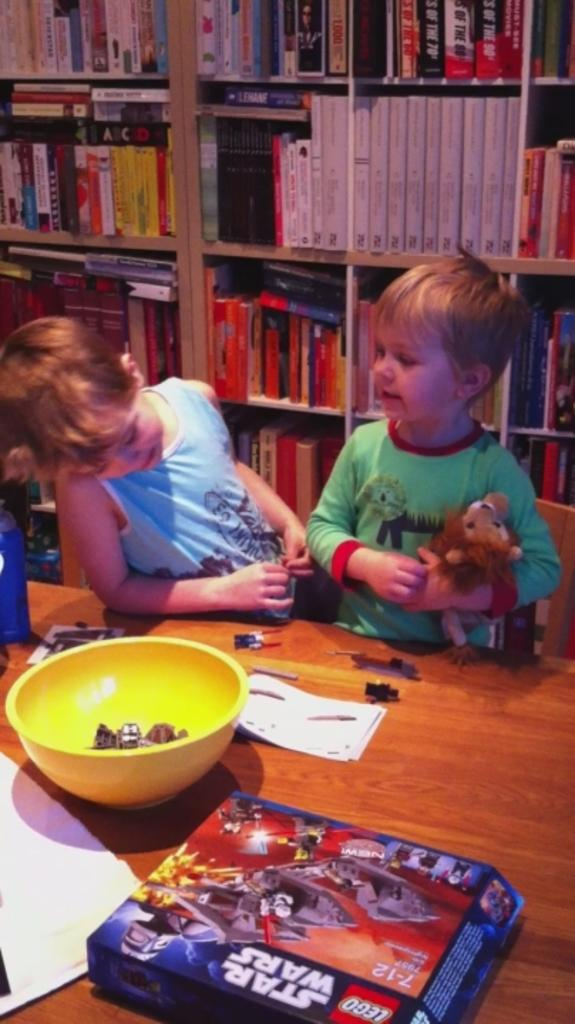How many children are in the image? There are 2 children in the image. What are the children holding in the image? The children are holding a toy. What is in front of the children? There is a table in front of the children. What items can be found on the table? Papers, a box, and a yellow bowl are present on the table. What is visible behind the children? There are bookshelves behind the children. What type of sense can be seen in the image? There is no sense present in the image; it is a visual representation of the scene. Can you describe the twig that the children are using to play with the toy? There is no twig present in the image; the children are holding a toy without any additional objects. 